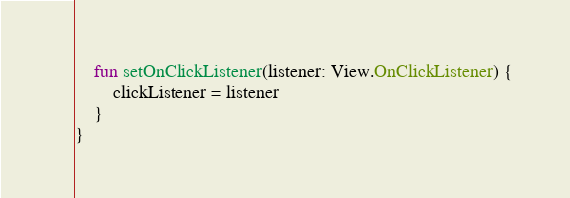<code> <loc_0><loc_0><loc_500><loc_500><_Kotlin_>    fun setOnClickListener(listener: View.OnClickListener) {
        clickListener = listener
    }
}
</code> 